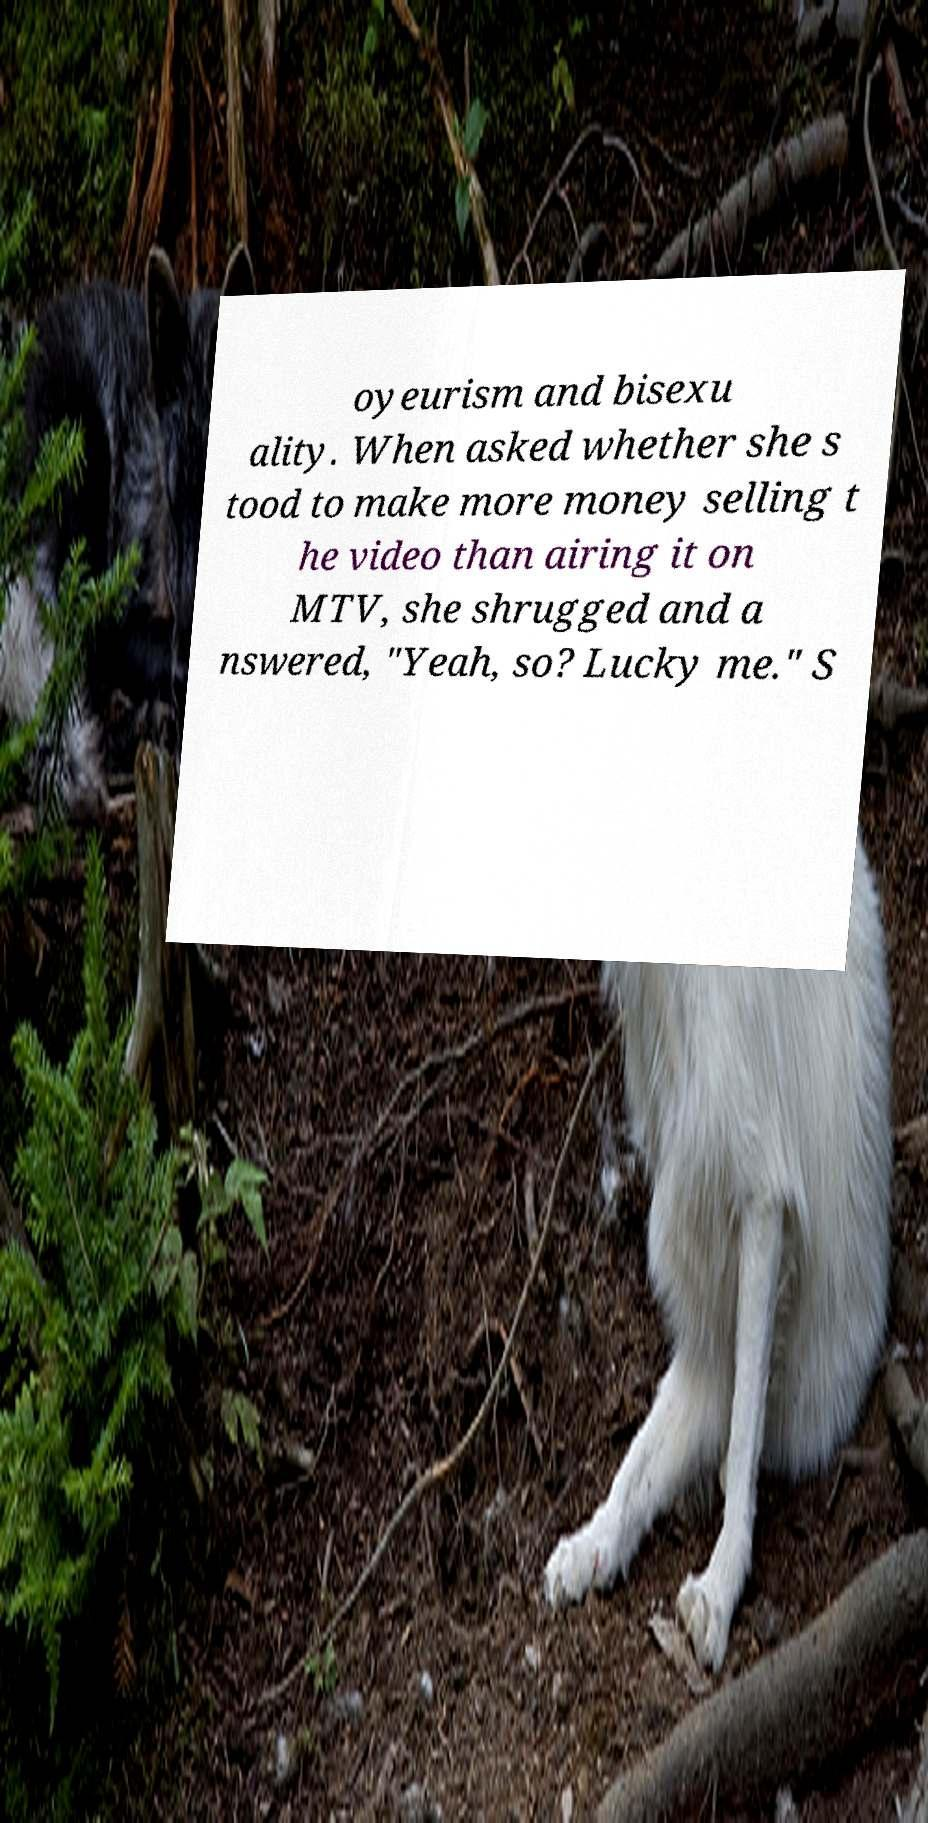Please identify and transcribe the text found in this image. oyeurism and bisexu ality. When asked whether she s tood to make more money selling t he video than airing it on MTV, she shrugged and a nswered, "Yeah, so? Lucky me." S 